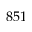Convert formula to latex. <formula><loc_0><loc_0><loc_500><loc_500>8 5 1</formula> 